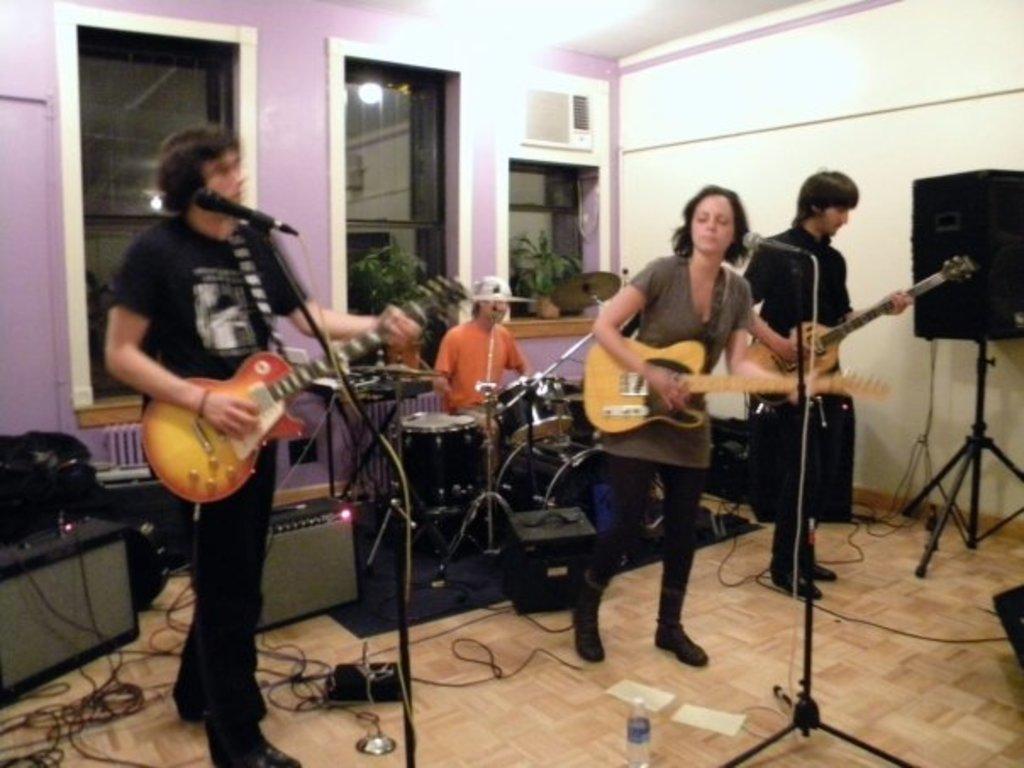How would you summarize this image in a sentence or two? In this image I can see the group of people playing the musical instruments. 